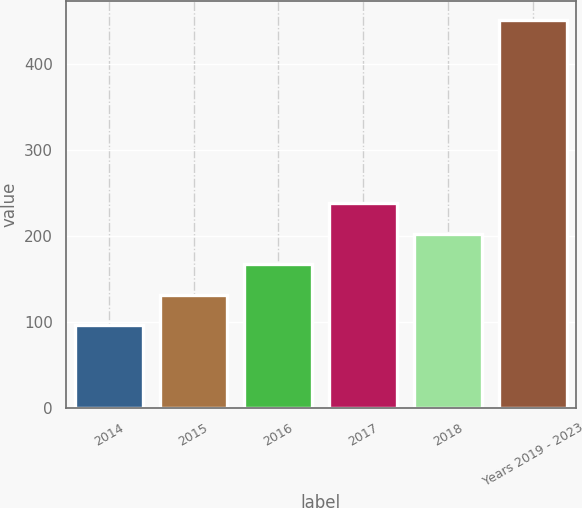Convert chart. <chart><loc_0><loc_0><loc_500><loc_500><bar_chart><fcel>2014<fcel>2015<fcel>2016<fcel>2017<fcel>2018<fcel>Years 2019 - 2023<nl><fcel>96<fcel>131.5<fcel>167<fcel>238<fcel>202.5<fcel>451<nl></chart> 